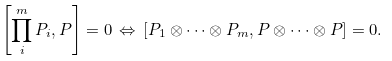<formula> <loc_0><loc_0><loc_500><loc_500>\left [ \prod _ { i } ^ { m } P _ { i } , P \right ] = 0 \, \Leftrightarrow \, \left [ P _ { 1 } \otimes \dots \otimes P _ { m } , P \otimes \dots \otimes P \right ] = 0 .</formula> 